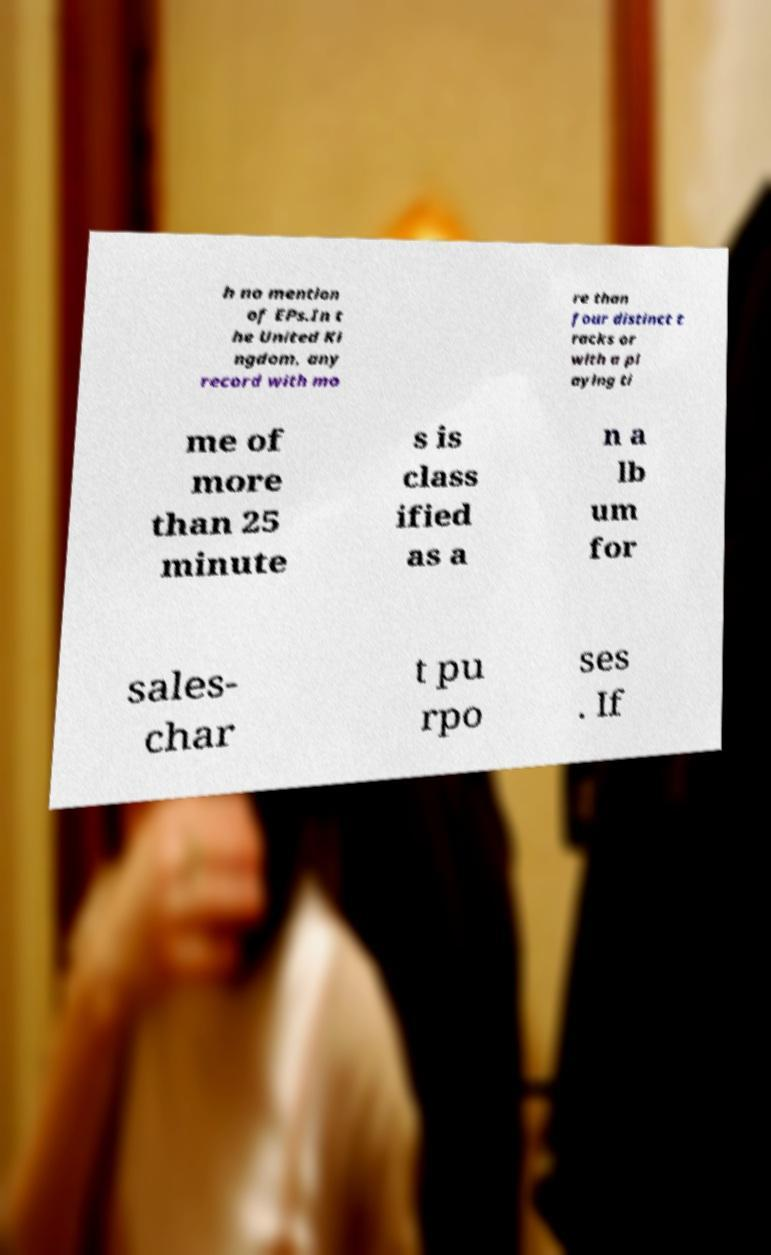Can you read and provide the text displayed in the image?This photo seems to have some interesting text. Can you extract and type it out for me? h no mention of EPs.In t he United Ki ngdom, any record with mo re than four distinct t racks or with a pl aying ti me of more than 25 minute s is class ified as a n a lb um for sales- char t pu rpo ses . If 